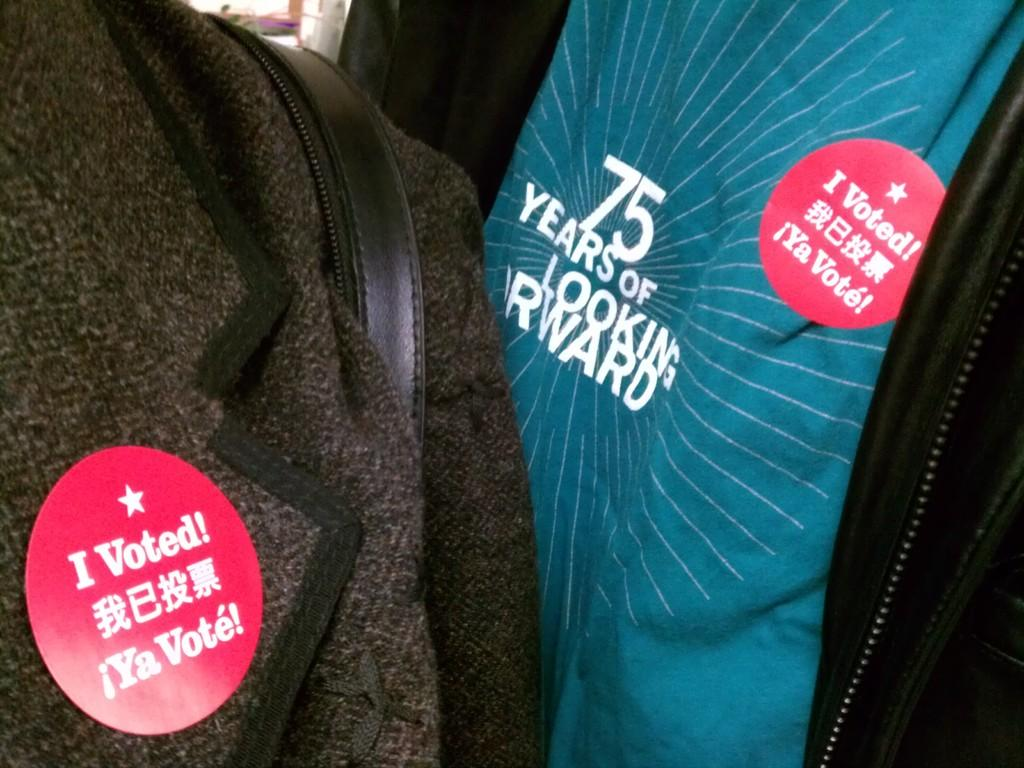How many people are in the image? There are two people in the image. What are the people wearing? The people are wearing coats. What can be seen on the coats of the two people? There are red color badges pinned on the coats of the two people. What type of blade is being used by the person in the image? There is no blade visible in the image. What type of tomatoes are being carried by the person in the image? There are no tomatoes present in the image. 